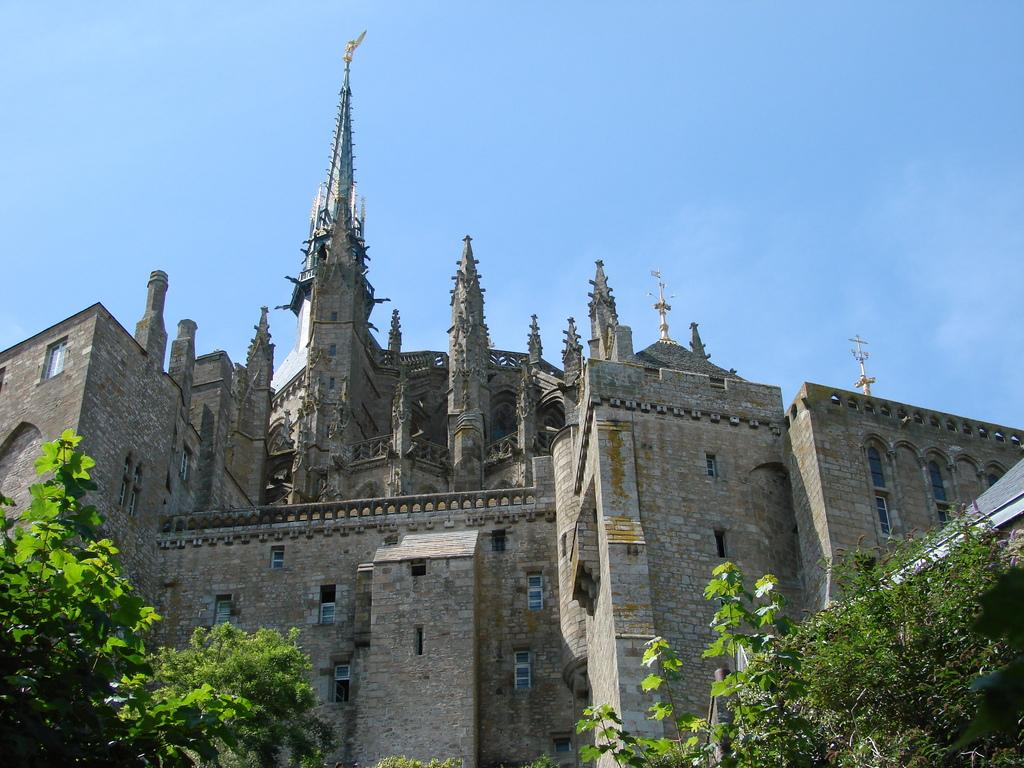What type of structure is in the image? There is a castle in the image. What type of natural vegetation is present in the image? There are trees in the image. What is visible at the top of the image? The sky is visible at the top of the image. What type of vessel is visible in the image? There is no vessel present in the image. What type of creature can be seen interacting with the castle in the image? There is no creature shown interacting with the castle in the image; only the castle and trees are present. 